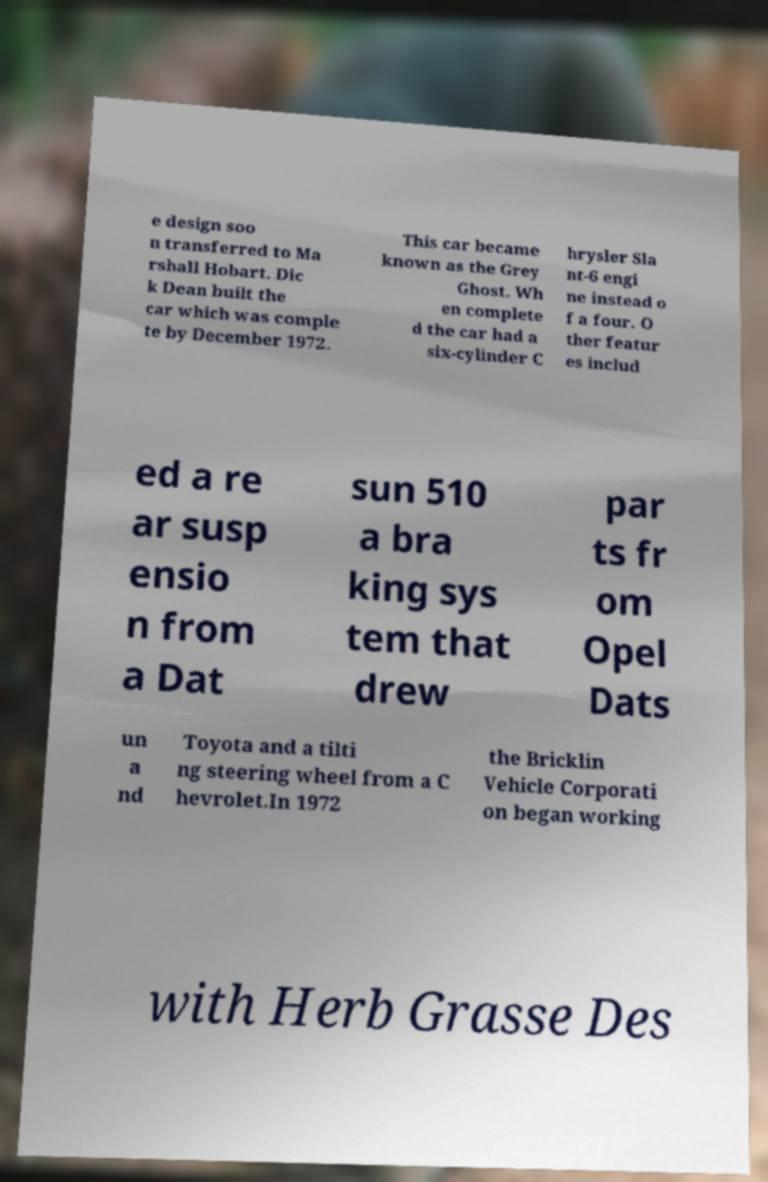Could you extract and type out the text from this image? e design soo n transferred to Ma rshall Hobart. Dic k Dean built the car which was comple te by December 1972. This car became known as the Grey Ghost. Wh en complete d the car had a six-cylinder C hrysler Sla nt-6 engi ne instead o f a four. O ther featur es includ ed a re ar susp ensio n from a Dat sun 510 a bra king sys tem that drew par ts fr om Opel Dats un a nd Toyota and a tilti ng steering wheel from a C hevrolet.In 1972 the Bricklin Vehicle Corporati on began working with Herb Grasse Des 